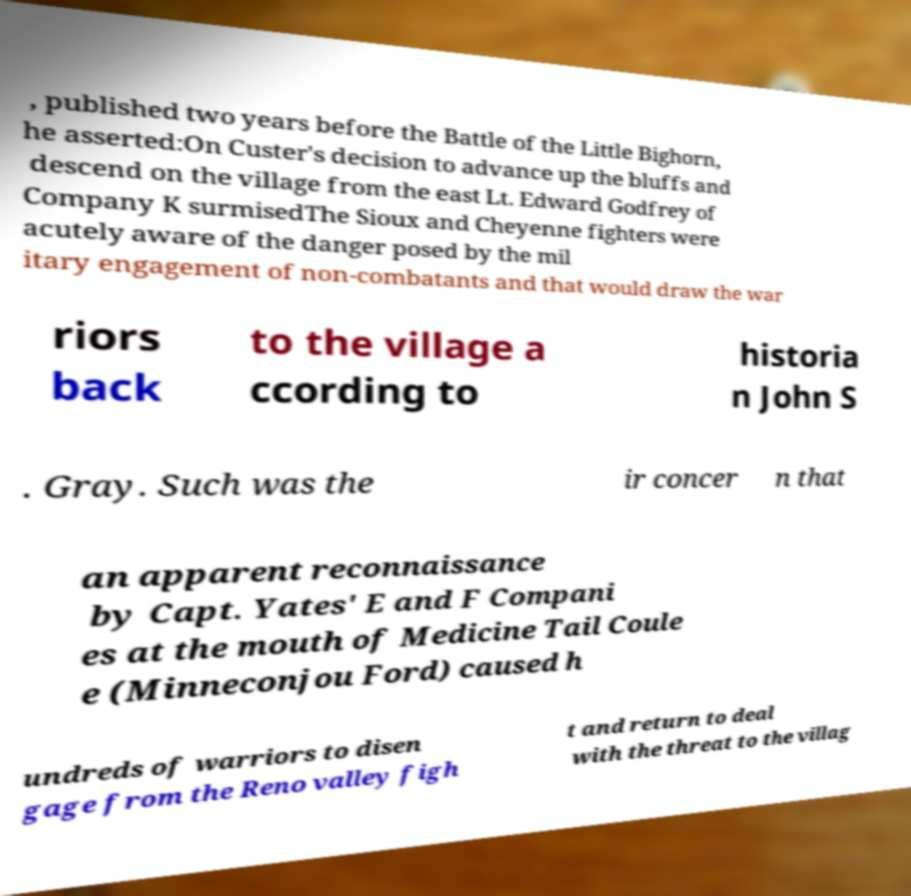Could you assist in decoding the text presented in this image and type it out clearly? , published two years before the Battle of the Little Bighorn, he asserted:On Custer's decision to advance up the bluffs and descend on the village from the east Lt. Edward Godfrey of Company K surmisedThe Sioux and Cheyenne fighters were acutely aware of the danger posed by the mil itary engagement of non-combatants and that would draw the war riors back to the village a ccording to historia n John S . Gray. Such was the ir concer n that an apparent reconnaissance by Capt. Yates' E and F Compani es at the mouth of Medicine Tail Coule e (Minneconjou Ford) caused h undreds of warriors to disen gage from the Reno valley figh t and return to deal with the threat to the villag 